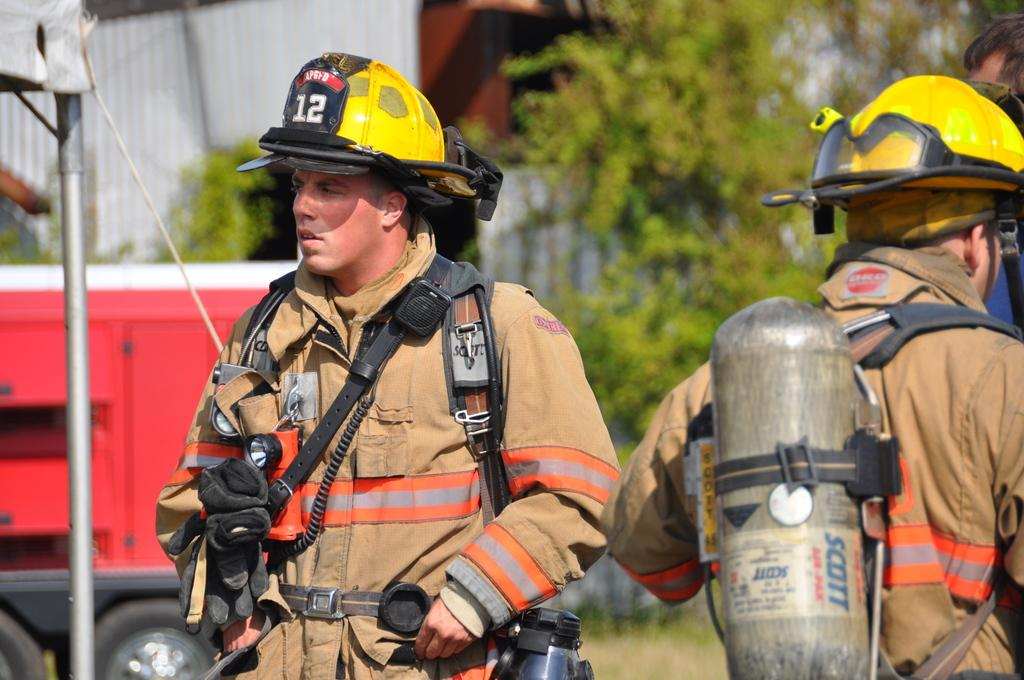How many people are present in the image? There are two persons standing in the image. What else can be seen in the image besides the people? There is a vehicle and a pole in the image. What is visible in the background of the image? There are trees in the background of the image. What type of paper is being used to create harmony between the two persons in the image? There is no paper or indication of harmony between the two persons in the image. 